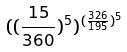Convert formula to latex. <formula><loc_0><loc_0><loc_500><loc_500>( ( \frac { 1 5 } { 3 6 0 } ) ^ { 5 } ) ^ { ( \frac { 3 2 6 } { 1 9 5 } ) ^ { 5 } }</formula> 